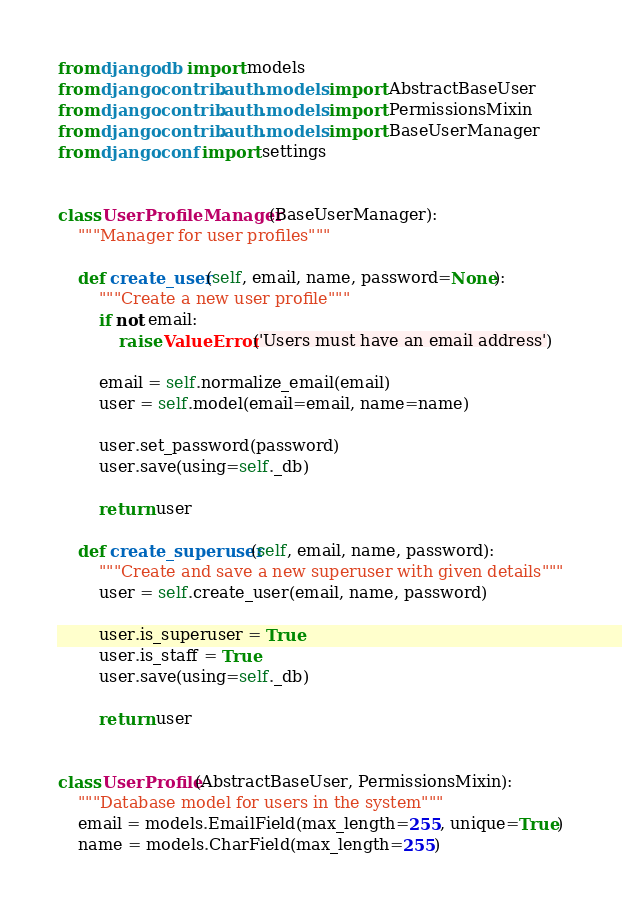Convert code to text. <code><loc_0><loc_0><loc_500><loc_500><_Python_>from django.db import models
from django.contrib.auth.models import AbstractBaseUser
from django.contrib.auth.models import PermissionsMixin
from django.contrib.auth.models import BaseUserManager
from django.conf import settings


class UserProfileManager(BaseUserManager):
    """Manager for user profiles"""

    def create_user(self, email, name, password=None):
        """Create a new user profile"""
        if not email:
            raise ValueError('Users must have an email address')

        email = self.normalize_email(email)
        user = self.model(email=email, name=name)
    
        user.set_password(password)
        user.save(using=self._db)

        return user

    def create_superuser(self, email, name, password):
        """Create and save a new superuser with given details"""
        user = self.create_user(email, name, password)

        user.is_superuser = True
        user.is_staff = True
        user.save(using=self._db)

        return user


class UserProfile(AbstractBaseUser, PermissionsMixin):
    """Database model for users in the system"""
    email = models.EmailField(max_length=255, unique=True)
    name = models.CharField(max_length=255)</code> 